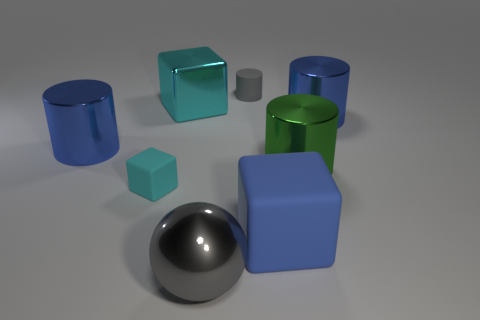What shapes are included in the scene? The image includes a variety of geometric shapes. There are cylinders, cubes, and a sphere. Some shapes like the blue cubes come in different sizes. Do the shapes have anything in common? Yes, despite their different shapes and sizes, all of the objects have a smooth surface finish and are displayed under similar lighting conditions, which suggests they might be part of a set or collection designed to showcase geometry or materials. 